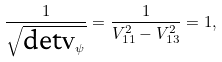Convert formula to latex. <formula><loc_0><loc_0><loc_500><loc_500>\frac { 1 } { \sqrt { \text {det} { \mathbf V } _ { \psi } } } = \frac { 1 } { V ^ { 2 } _ { 1 1 } - V ^ { 2 } _ { 1 3 } } = 1 ,</formula> 